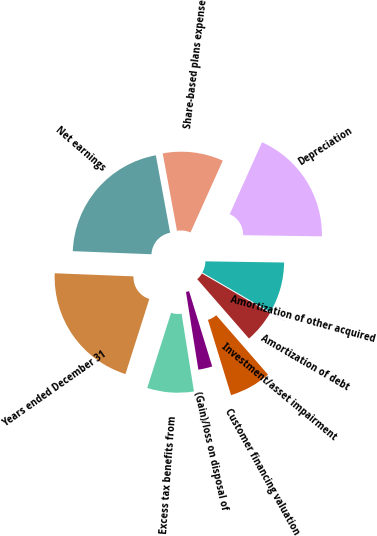Convert chart. <chart><loc_0><loc_0><loc_500><loc_500><pie_chart><fcel>Years ended December 31<fcel>Net earnings<fcel>Share-based plans expense<fcel>Depreciation<fcel>Amortization of other acquired<fcel>Amortization of debt<fcel>Investment/asset impairment<fcel>Customer financing valuation<fcel>(Gain)/loss on disposal of<fcel>Excess tax benefits from<nl><fcel>20.73%<fcel>21.47%<fcel>9.63%<fcel>18.51%<fcel>8.15%<fcel>0.01%<fcel>5.19%<fcel>6.67%<fcel>2.23%<fcel>7.41%<nl></chart> 